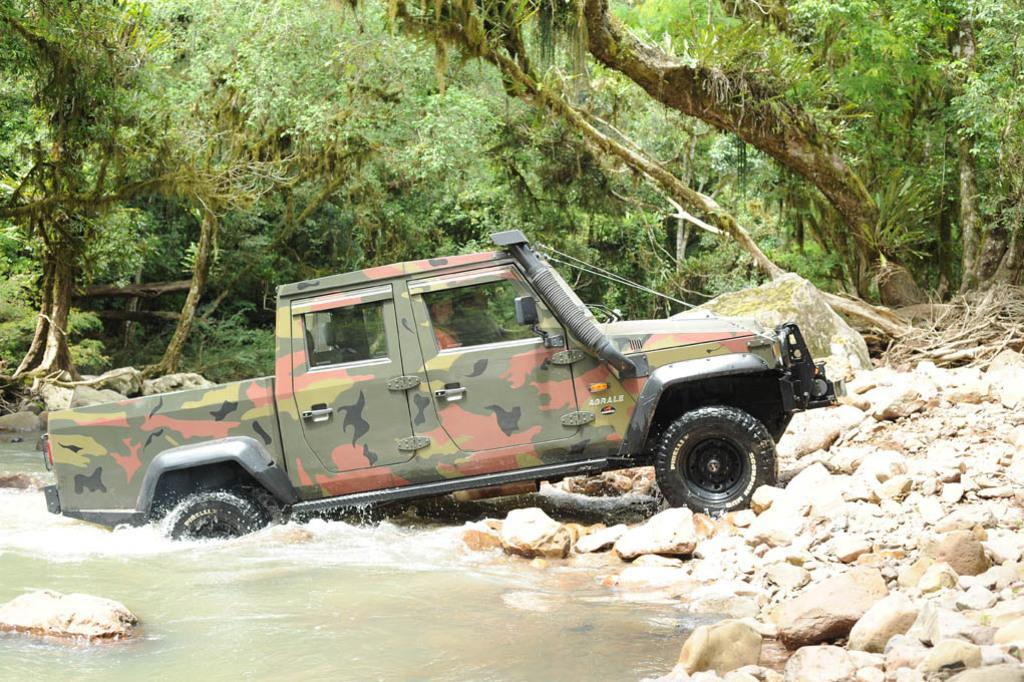What is the main subject in the center of the image? There is a vehicle in the center of the image. What can be seen at the bottom of the image? There is a pond at the bottom of the image. What is located near the pond? There are rocks near the pond. What type of vegetation is visible in the background of the image? There are trees and grass visible in the background of the image. Can you tell me how many yaks are grazing near the vehicle in the image? There are no yaks present in the image; it features a vehicle, a pond, rocks, trees, and grass. What advice does the father give to the person driving the vehicle in the image? There is no father or person driving the vehicle in the image, so it is not possible to answer that question. 